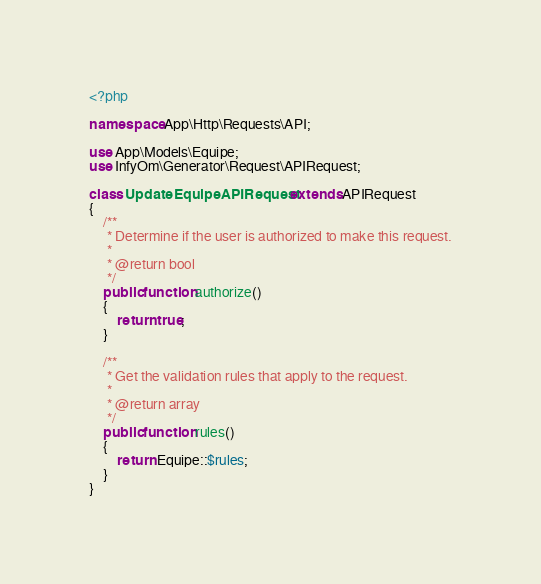<code> <loc_0><loc_0><loc_500><loc_500><_PHP_><?php

namespace App\Http\Requests\API;

use App\Models\Equipe;
use InfyOm\Generator\Request\APIRequest;

class UpdateEquipeAPIRequest extends APIRequest
{
    /**
     * Determine if the user is authorized to make this request.
     *
     * @return bool
     */
    public function authorize()
    {
        return true;
    }

    /**
     * Get the validation rules that apply to the request.
     *
     * @return array
     */
    public function rules()
    {
        return Equipe::$rules;
    }
}
</code> 